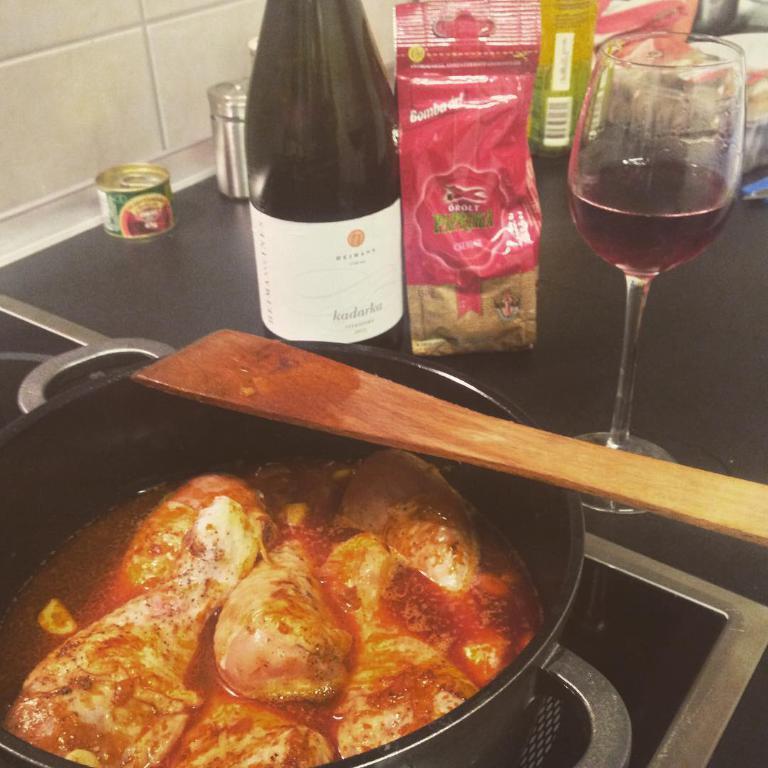In one or two sentences, can you explain what this image depicts? On a gas stove there is a bowl with food in it and a stick. Beside it there are bottle,glass with liquid,food packets,etc. 